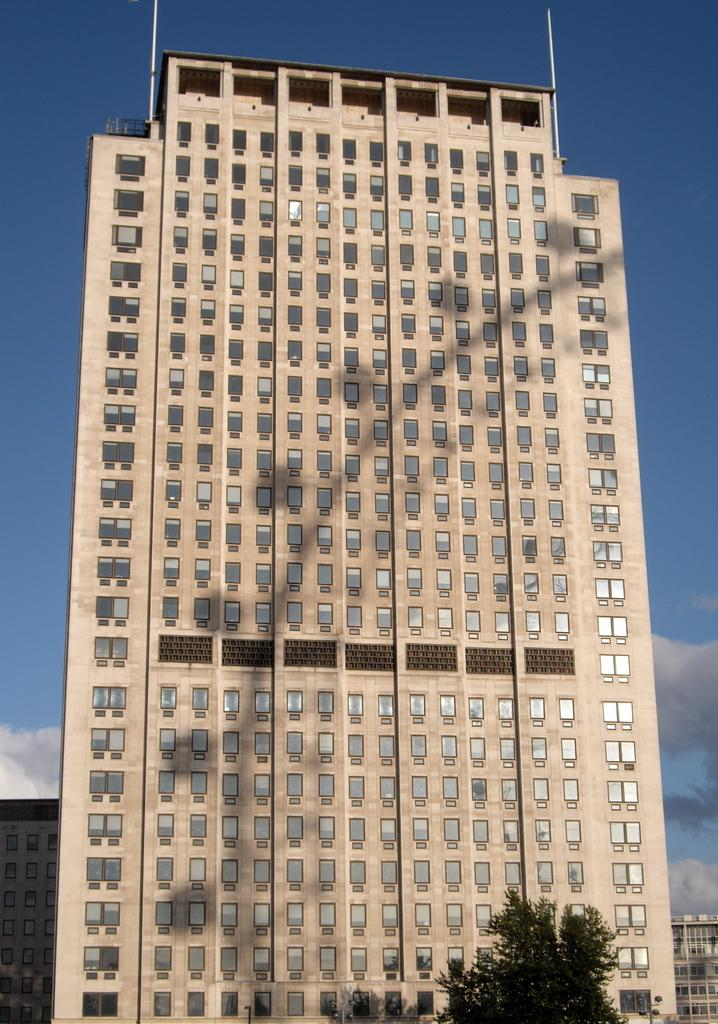What is the main structure in the image? There is a building in the image. What is located at the top of the building? There are two poles at the top of the building. What type of vegetation can be seen at the bottom of the image? Trees are visible at the bottom of the image. What can be seen in the background of the image? There are many buildings and the sky visible in the background of the image. What is the weather like in the image? The presence of clouds in the background suggests that it might be partly cloudy. What type of humor can be seen in the image? There is no humor present in the image; it is a picture of a building with two poles at the top and trees at the bottom. What type of seed is being planted in the image? There is no seed or planting activity depicted in the image. 